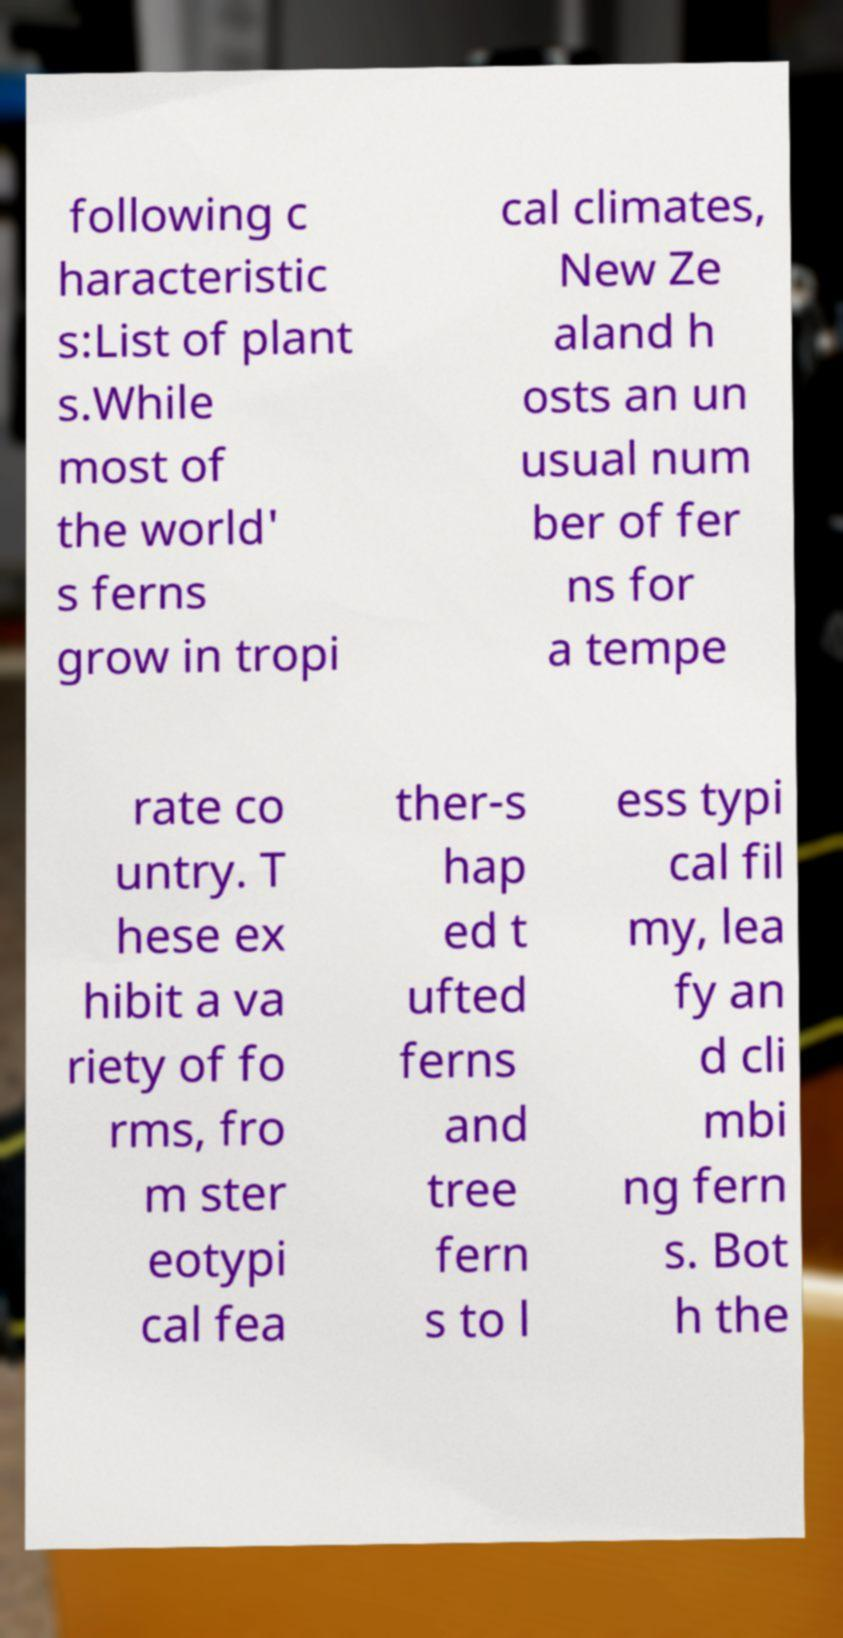There's text embedded in this image that I need extracted. Can you transcribe it verbatim? following c haracteristic s:List of plant s.While most of the world' s ferns grow in tropi cal climates, New Ze aland h osts an un usual num ber of fer ns for a tempe rate co untry. T hese ex hibit a va riety of fo rms, fro m ster eotypi cal fea ther-s hap ed t ufted ferns and tree fern s to l ess typi cal fil my, lea fy an d cli mbi ng fern s. Bot h the 